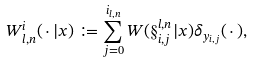Convert formula to latex. <formula><loc_0><loc_0><loc_500><loc_500>W _ { l , n } ^ { i } ( \, \cdot \, | x ) & \coloneqq \sum _ { j = 0 } ^ { i _ { l , n } } W ( \S _ { i , j } ^ { l , n } | x ) \delta _ { y _ { i , j } } ( \, \cdot \, ) ,</formula> 